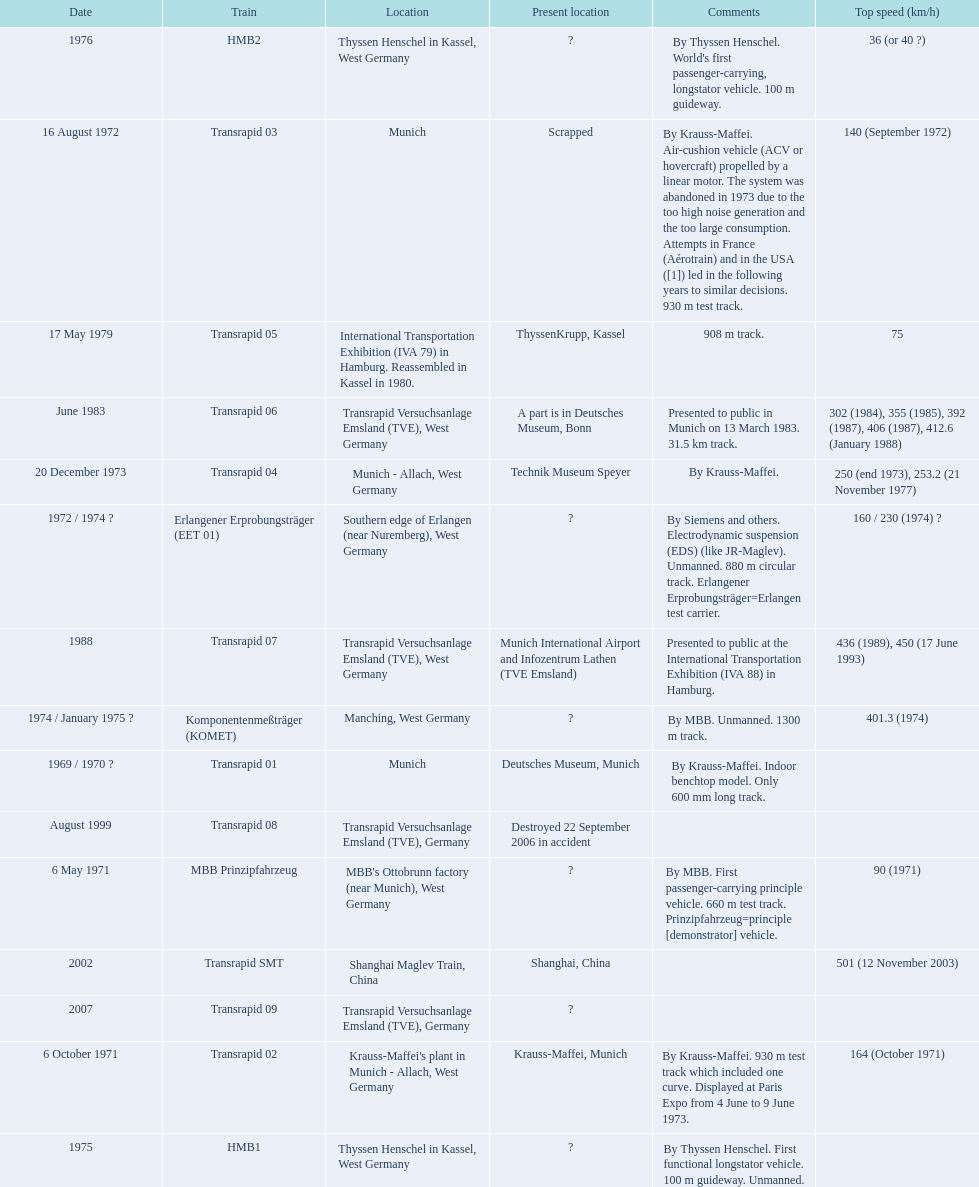Which trains had a top speed listed? MBB Prinzipfahrzeug, Transrapid 02, Transrapid 03, Erlangener Erprobungsträger (EET 01), Transrapid 04, Komponentenmeßträger (KOMET), HMB2, Transrapid 05, Transrapid 06, Transrapid 07, Transrapid SMT. Which ones list munich as a location? MBB Prinzipfahrzeug, Transrapid 02, Transrapid 03. Of these which ones present location is known? Transrapid 02, Transrapid 03. Which of those is no longer in operation? Transrapid 03. 